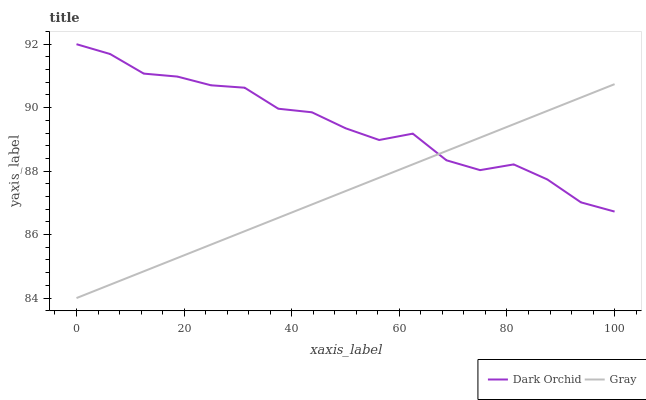Does Gray have the minimum area under the curve?
Answer yes or no. Yes. Does Dark Orchid have the maximum area under the curve?
Answer yes or no. Yes. Does Dark Orchid have the minimum area under the curve?
Answer yes or no. No. Is Gray the smoothest?
Answer yes or no. Yes. Is Dark Orchid the roughest?
Answer yes or no. Yes. Is Dark Orchid the smoothest?
Answer yes or no. No. Does Gray have the lowest value?
Answer yes or no. Yes. Does Dark Orchid have the lowest value?
Answer yes or no. No. Does Dark Orchid have the highest value?
Answer yes or no. Yes. Does Gray intersect Dark Orchid?
Answer yes or no. Yes. Is Gray less than Dark Orchid?
Answer yes or no. No. Is Gray greater than Dark Orchid?
Answer yes or no. No. 